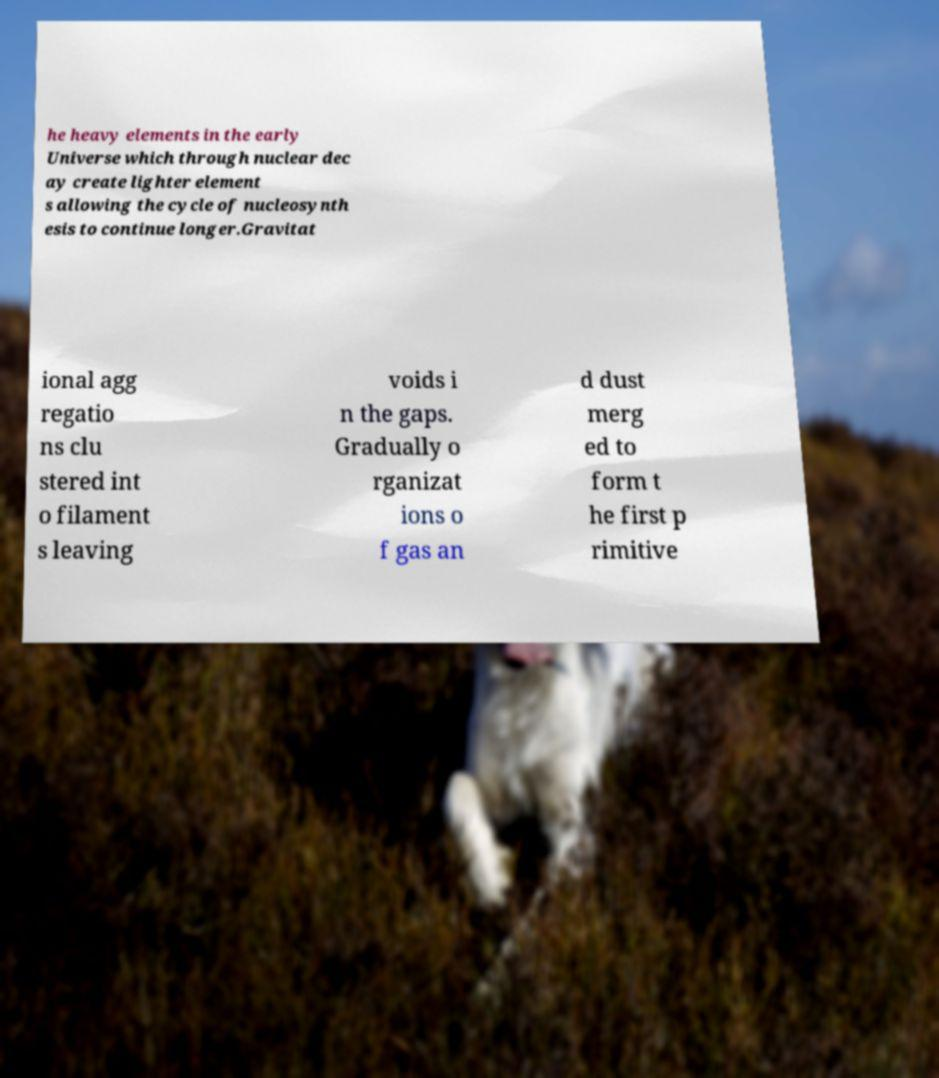For documentation purposes, I need the text within this image transcribed. Could you provide that? he heavy elements in the early Universe which through nuclear dec ay create lighter element s allowing the cycle of nucleosynth esis to continue longer.Gravitat ional agg regatio ns clu stered int o filament s leaving voids i n the gaps. Gradually o rganizat ions o f gas an d dust merg ed to form t he first p rimitive 